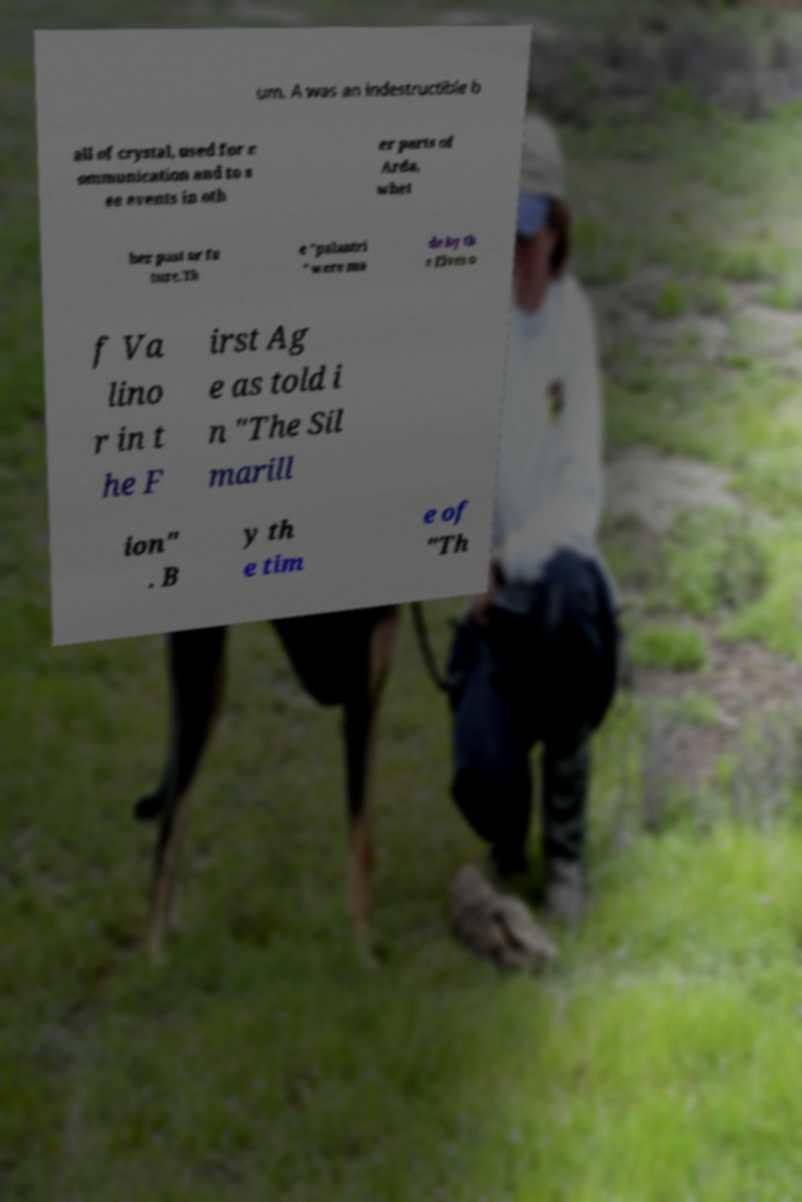I need the written content from this picture converted into text. Can you do that? um. A was an indestructible b all of crystal, used for c ommunication and to s ee events in oth er parts of Arda, whet her past or fu ture.Th e "palantri " were ma de by th e Elves o f Va lino r in t he F irst Ag e as told i n "The Sil marill ion" . B y th e tim e of "Th 